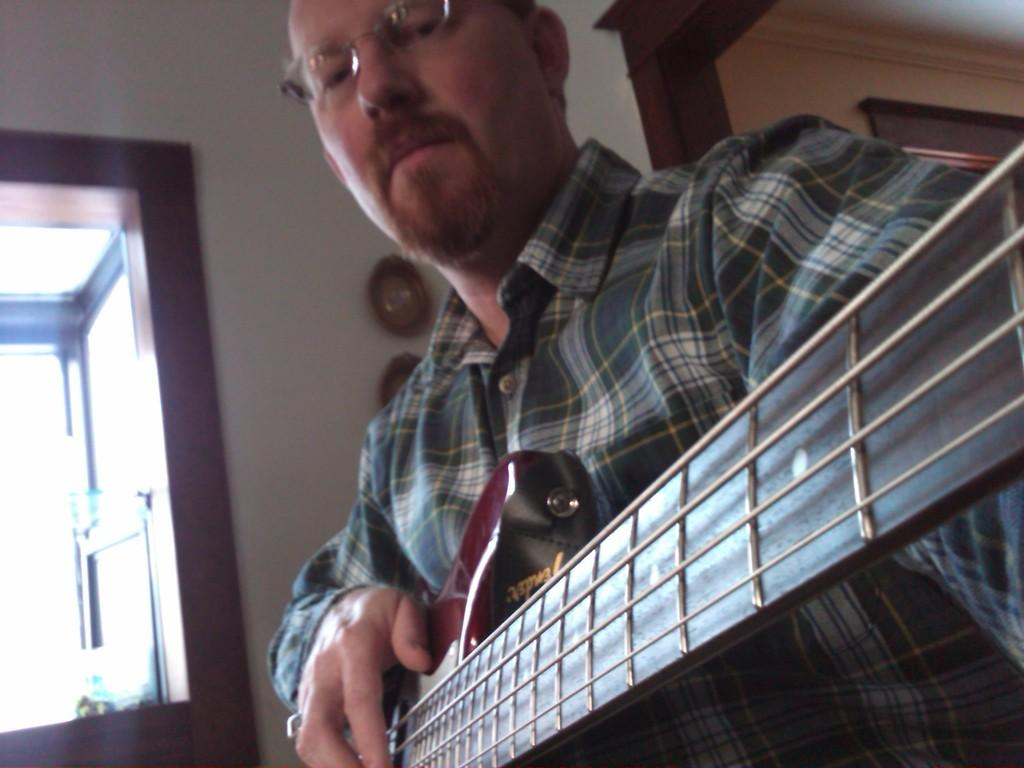What is the man in the image doing? The man is playing the guitar. What can be seen in the background of the image? There is a wall and a window in the background of the image. How many mice are visible in the image? There are no mice present in the image. What type of wound is the man treating in the image? There is no wound visible in the image; the man is playing the guitar. 